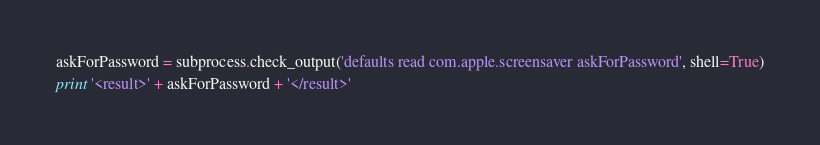Convert code to text. <code><loc_0><loc_0><loc_500><loc_500><_Python_>
askForPassword = subprocess.check_output('defaults read com.apple.screensaver askForPassword', shell=True)

print '<result>' + askForPassword + '</result>'
</code> 